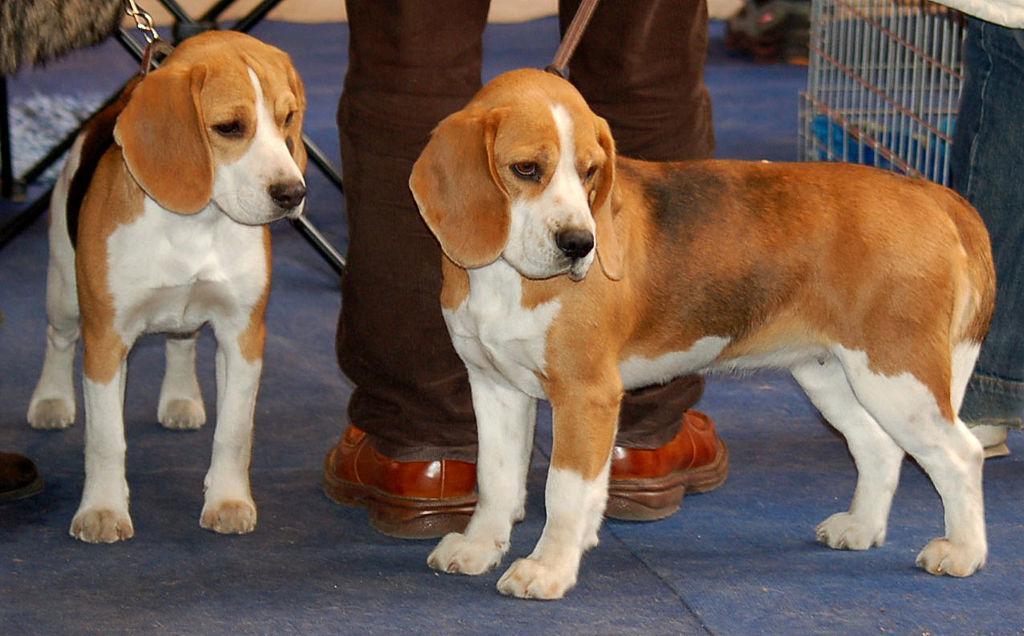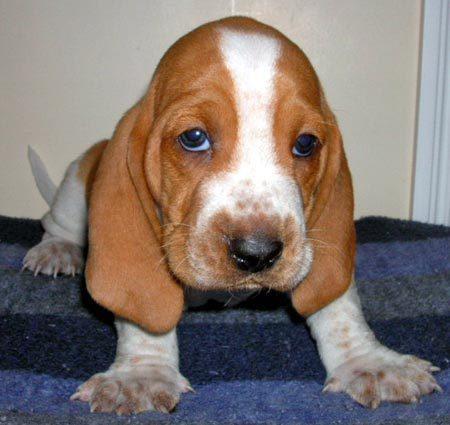The first image is the image on the left, the second image is the image on the right. Evaluate the accuracy of this statement regarding the images: "One of the basset hounds is sitting in the grass.". Is it true? Answer yes or no. No. The first image is the image on the left, the second image is the image on the right. Given the left and right images, does the statement "One image has no less than two dogs in it." hold true? Answer yes or no. Yes. 